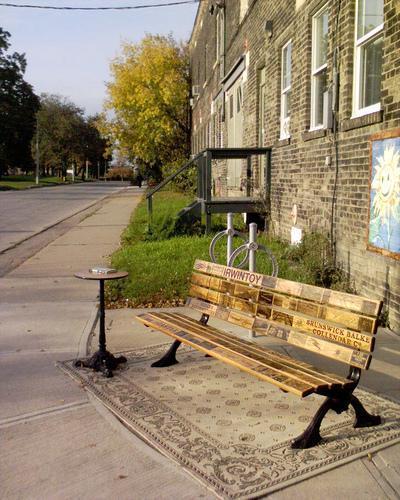How many benches?
Give a very brief answer. 1. How many people are holding an umbrella?
Give a very brief answer. 0. 